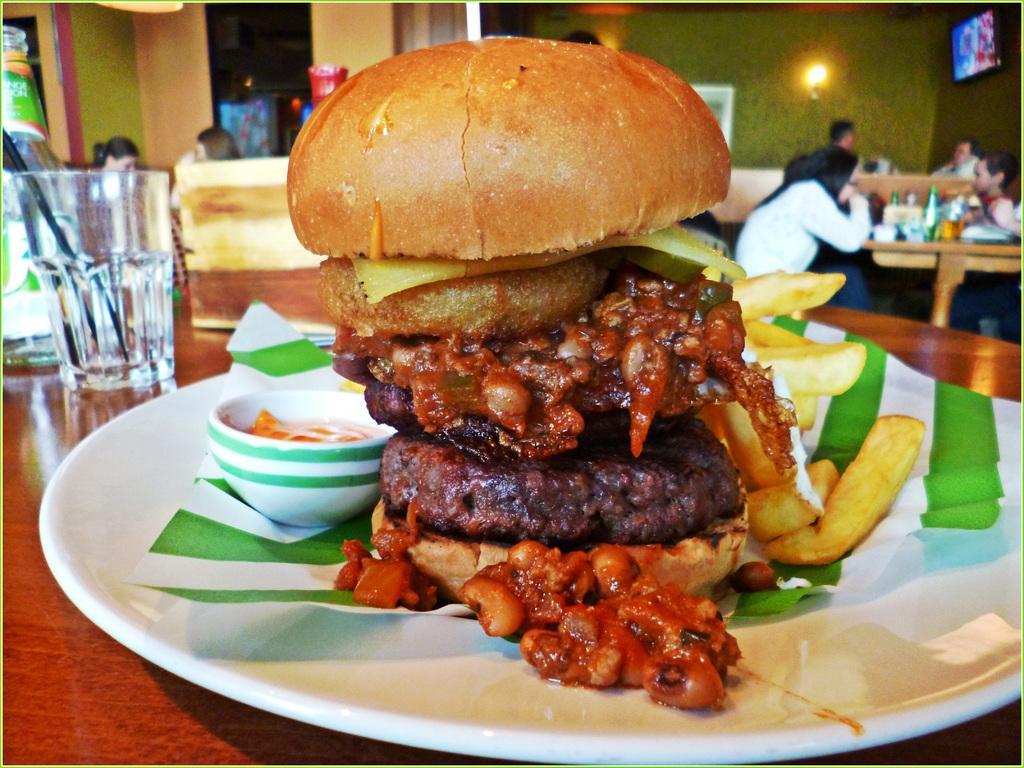Could you give a brief overview of what you see in this image? In the picture I can see people sitting in front of tables. On tables I can see bottles, glasses, food items in plates and some other objects. In the background I can see a TV, lights attached to the wall and some other objects. The background of the image is blurred. 